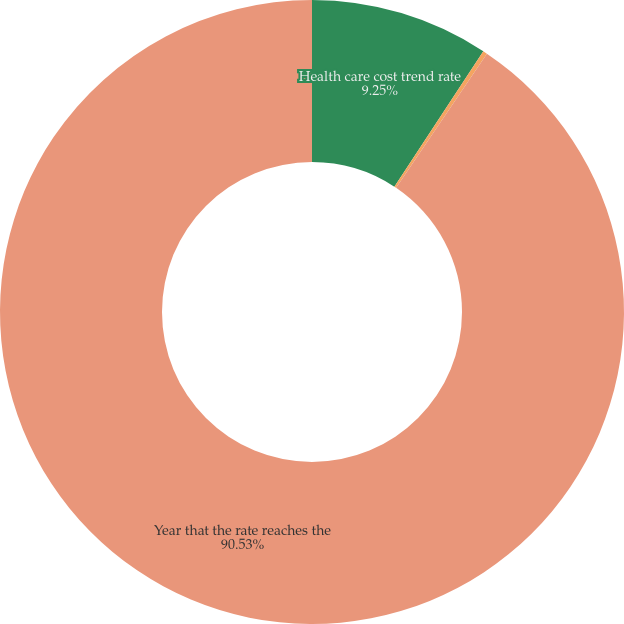Convert chart to OTSL. <chart><loc_0><loc_0><loc_500><loc_500><pie_chart><fcel>Health care cost trend rate<fcel>Rate to which the cost trend<fcel>Year that the rate reaches the<nl><fcel>9.25%<fcel>0.22%<fcel>90.52%<nl></chart> 